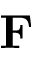<formula> <loc_0><loc_0><loc_500><loc_500>F</formula> 